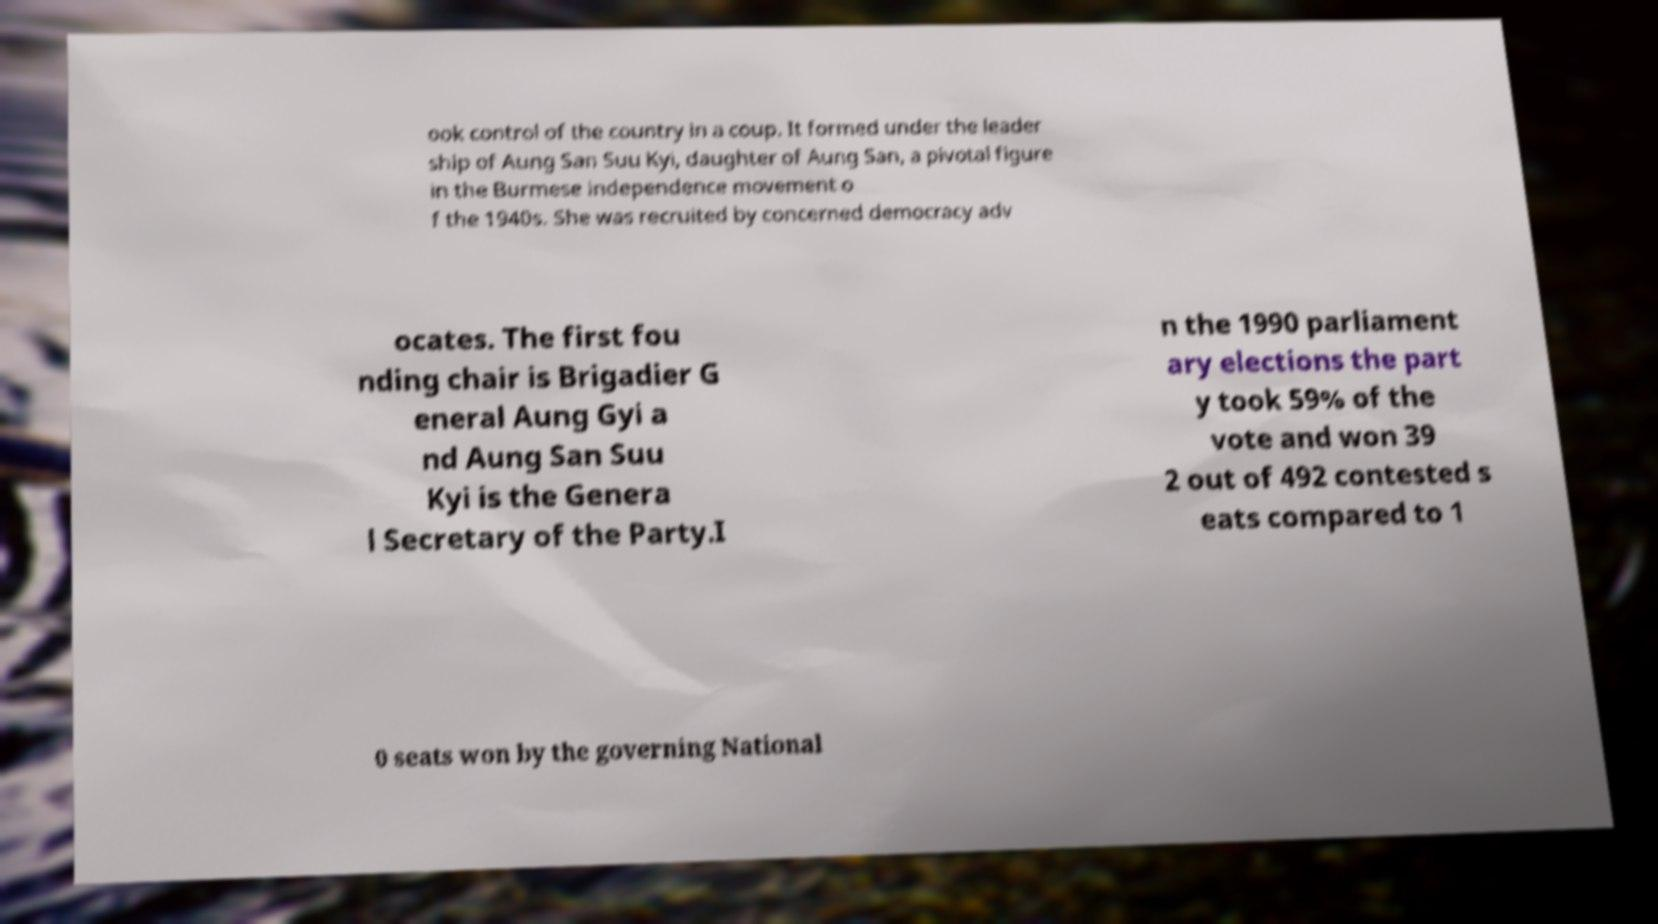Can you read and provide the text displayed in the image?This photo seems to have some interesting text. Can you extract and type it out for me? ook control of the country in a coup. It formed under the leader ship of Aung San Suu Kyi, daughter of Aung San, a pivotal figure in the Burmese independence movement o f the 1940s. She was recruited by concerned democracy adv ocates. The first fou nding chair is Brigadier G eneral Aung Gyi a nd Aung San Suu Kyi is the Genera l Secretary of the Party.I n the 1990 parliament ary elections the part y took 59% of the vote and won 39 2 out of 492 contested s eats compared to 1 0 seats won by the governing National 